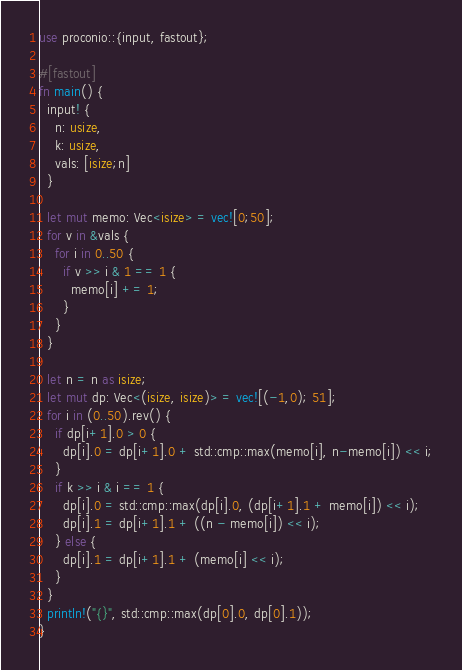Convert code to text. <code><loc_0><loc_0><loc_500><loc_500><_Rust_>use proconio::{input, fastout};

#[fastout]
fn main() {
  input! {
    n: usize,
    k: usize,
    vals: [isize;n]
  }
  
  let mut memo: Vec<isize> = vec![0;50];
  for v in &vals {
    for i in 0..50 {
      if v >> i & 1 == 1 {
        memo[i] += 1;
      }
    }
  }

  let n = n as isize;
  let mut dp: Vec<(isize, isize)> = vec![(-1,0); 51];
  for i in (0..50).rev() {
    if dp[i+1].0 > 0 {
      dp[i].0 = dp[i+1].0 + std::cmp::max(memo[i], n-memo[i]) << i;
    }
    if k >> i & i == 1 {
      dp[i].0 = std::cmp::max(dp[i].0, (dp[i+1].1 + memo[i]) << i);
      dp[i].1 = dp[i+1].1 + ((n - memo[i]) << i);
    } else {
      dp[i].1 = dp[i+1].1 + (memo[i] << i);
    }
  }
  println!("{}", std::cmp::max(dp[0].0, dp[0].1));
}</code> 